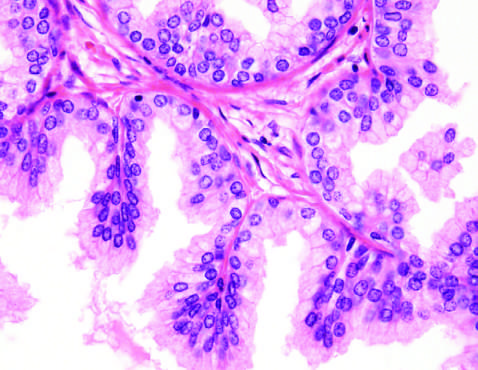what is the nodularity caused by in other cases of nodular hyperplasia?
Answer the question using a single word or phrase. Stromal 